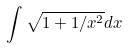Convert formula to latex. <formula><loc_0><loc_0><loc_500><loc_500>\int \sqrt { 1 + 1 / x ^ { 2 } } d x</formula> 